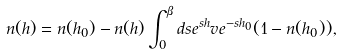Convert formula to latex. <formula><loc_0><loc_0><loc_500><loc_500>n ( h ) = n ( h _ { 0 } ) - n ( h ) \int _ { 0 } ^ { \beta } d s e ^ { s h } v e ^ { - s h _ { 0 } } ( 1 - n ( h _ { 0 } ) ) ,</formula> 